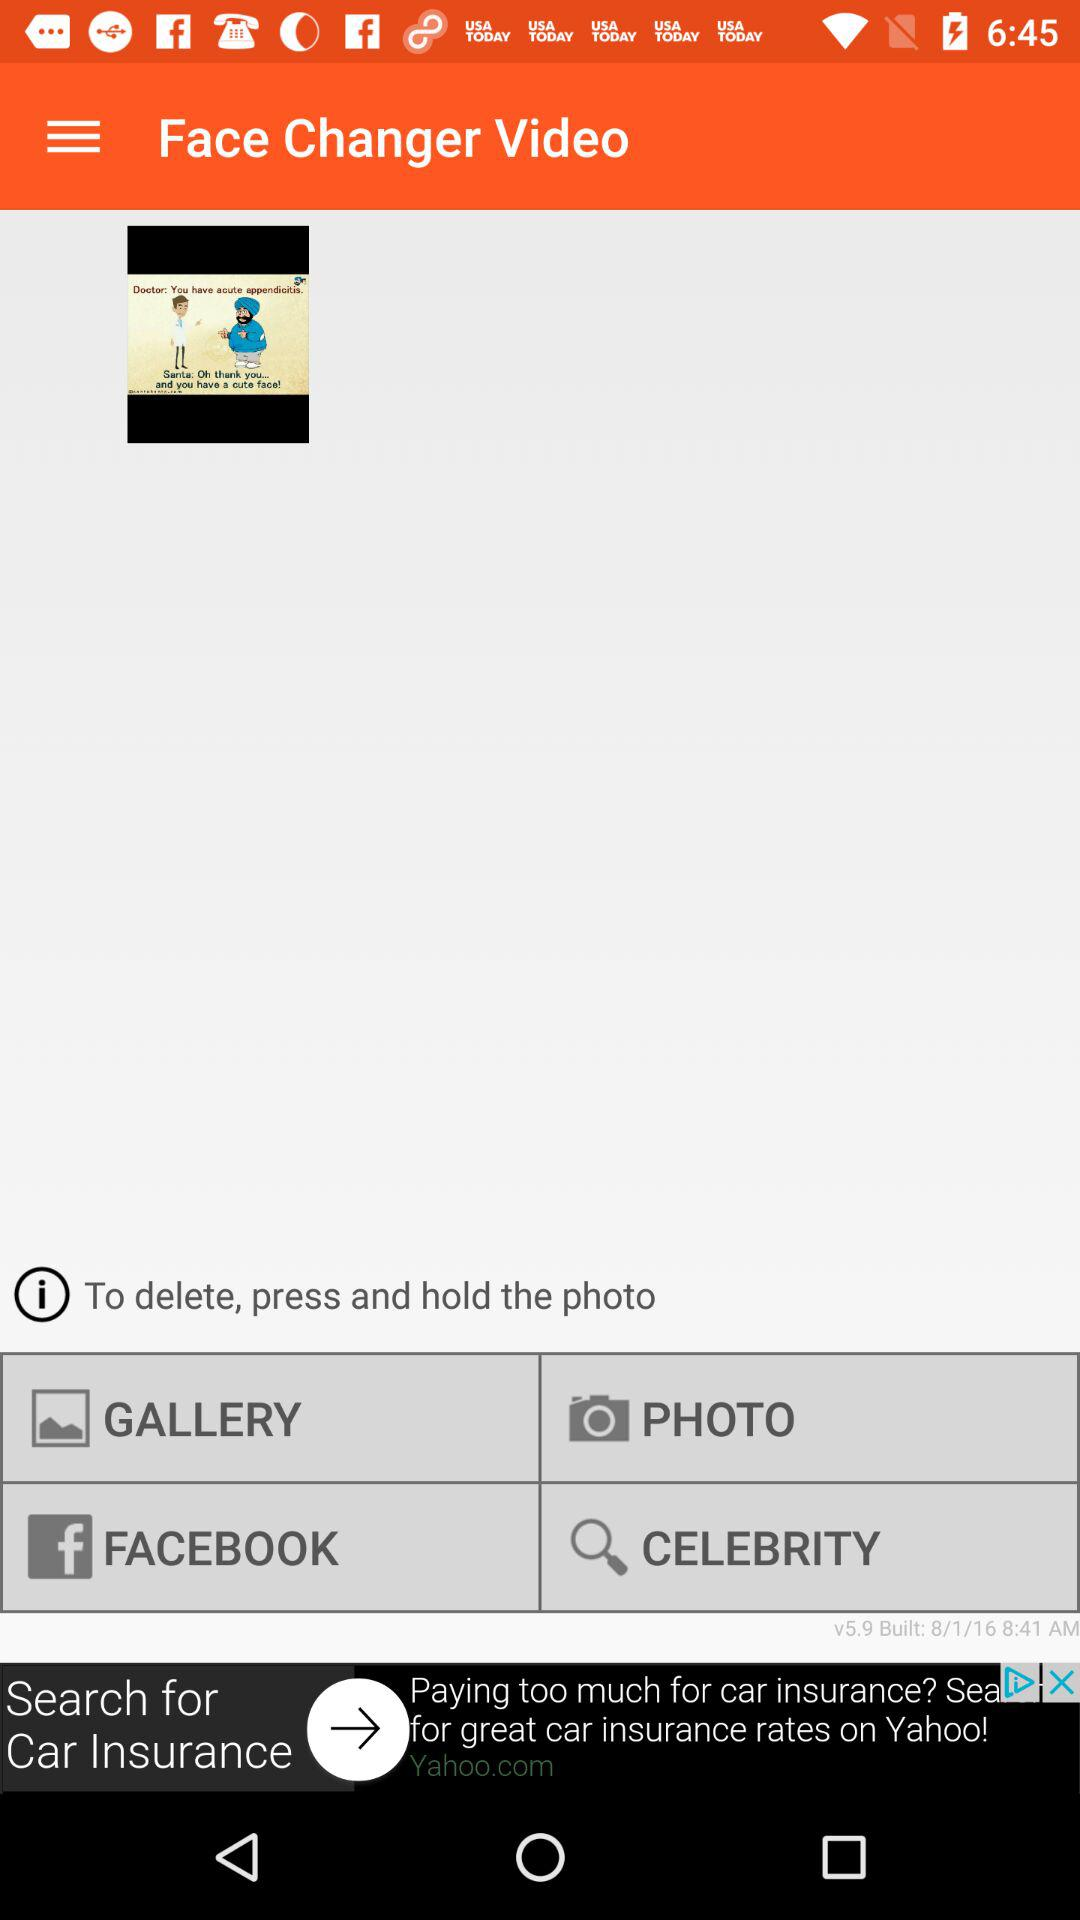What is the procedure to delete a photo? The procedure is "To delete, press and hold the photo". 